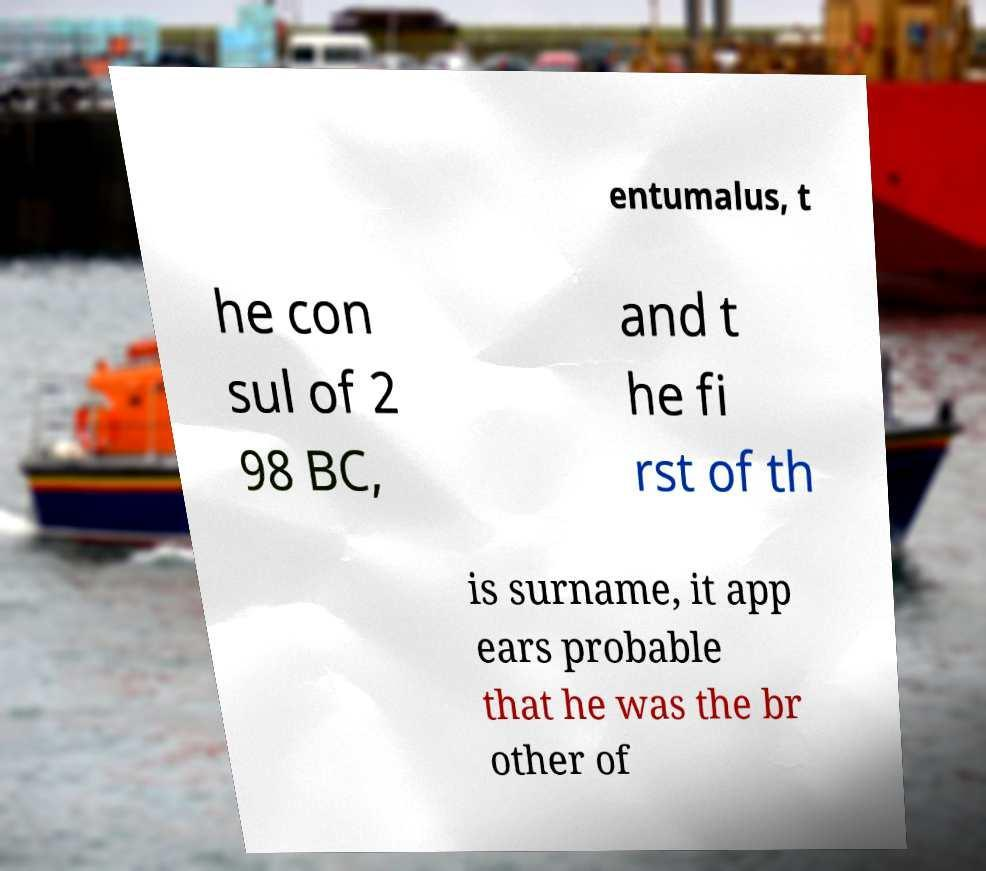There's text embedded in this image that I need extracted. Can you transcribe it verbatim? entumalus, t he con sul of 2 98 BC, and t he fi rst of th is surname, it app ears probable that he was the br other of 